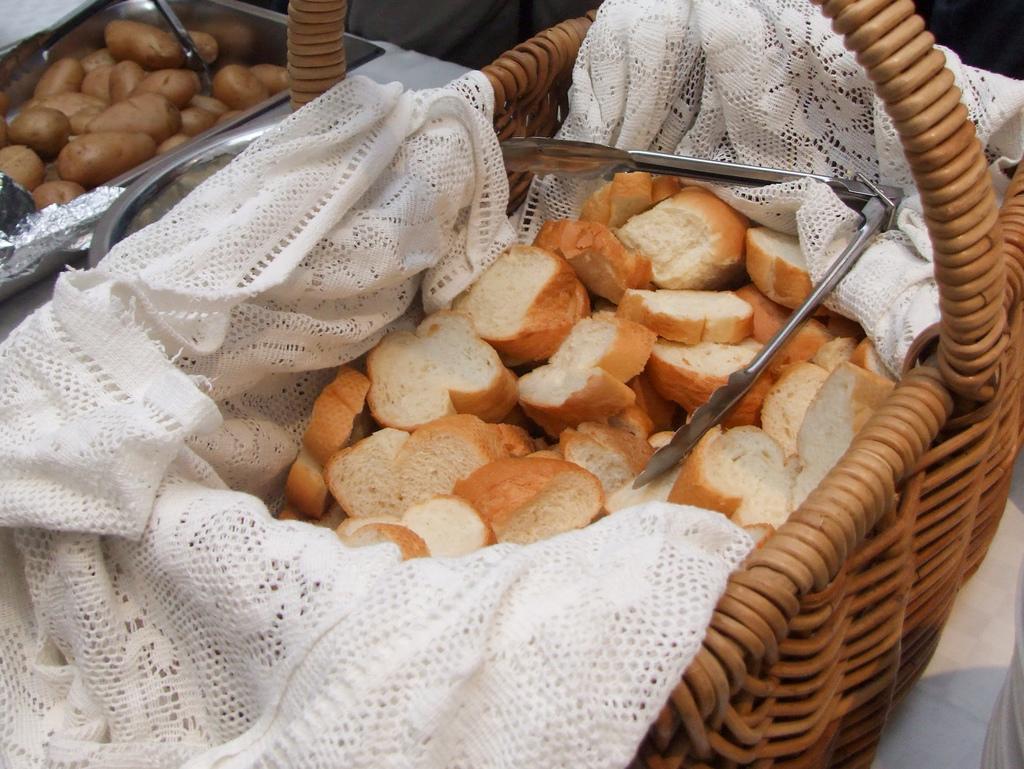How would you summarize this image in a sentence or two? In this picture, we can see some food items in baskets and container, we can see basket with white cloth and some metallic object, we can see some white color object in the bottom right side of the picture. 